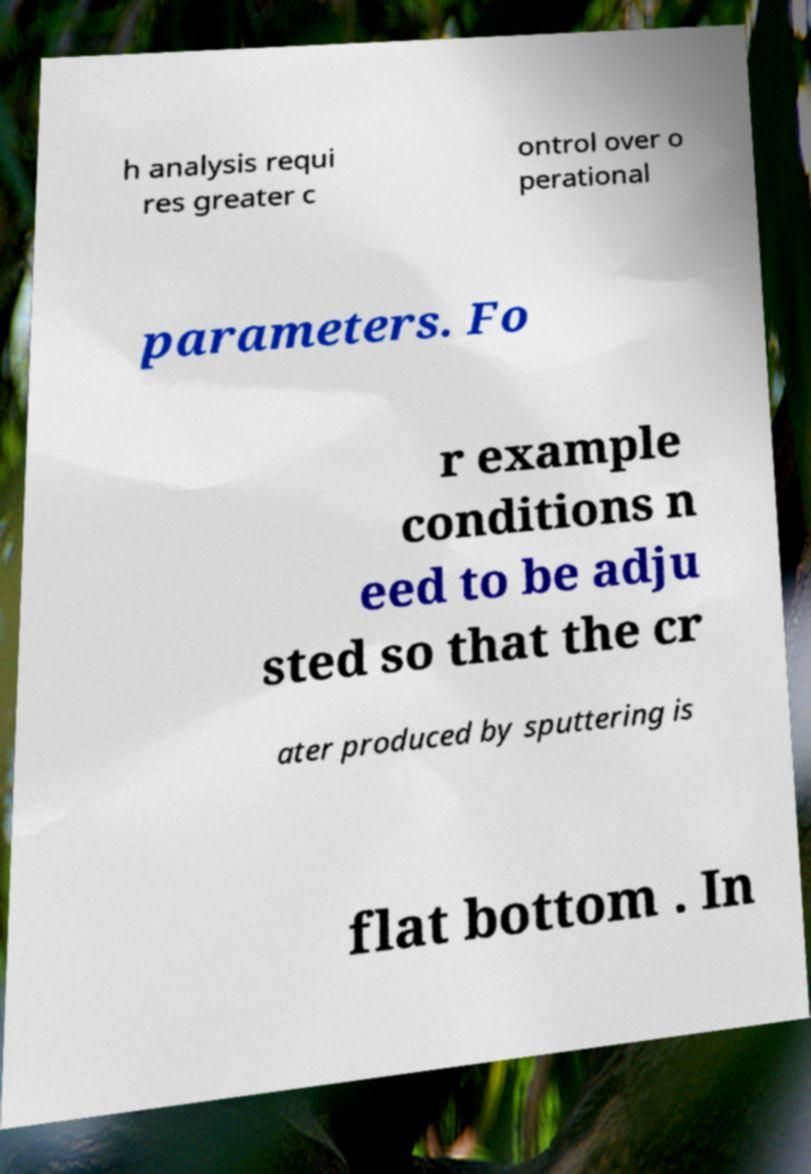Could you extract and type out the text from this image? h analysis requi res greater c ontrol over o perational parameters. Fo r example conditions n eed to be adju sted so that the cr ater produced by sputtering is flat bottom . In 